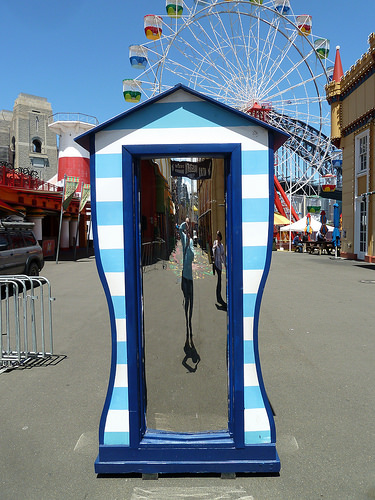<image>
Is there a giant wheel next to the door? No. The giant wheel is not positioned next to the door. They are located in different areas of the scene. Where is the women in relation to the mirror? Is it in front of the mirror? Yes. The women is positioned in front of the mirror, appearing closer to the camera viewpoint. 